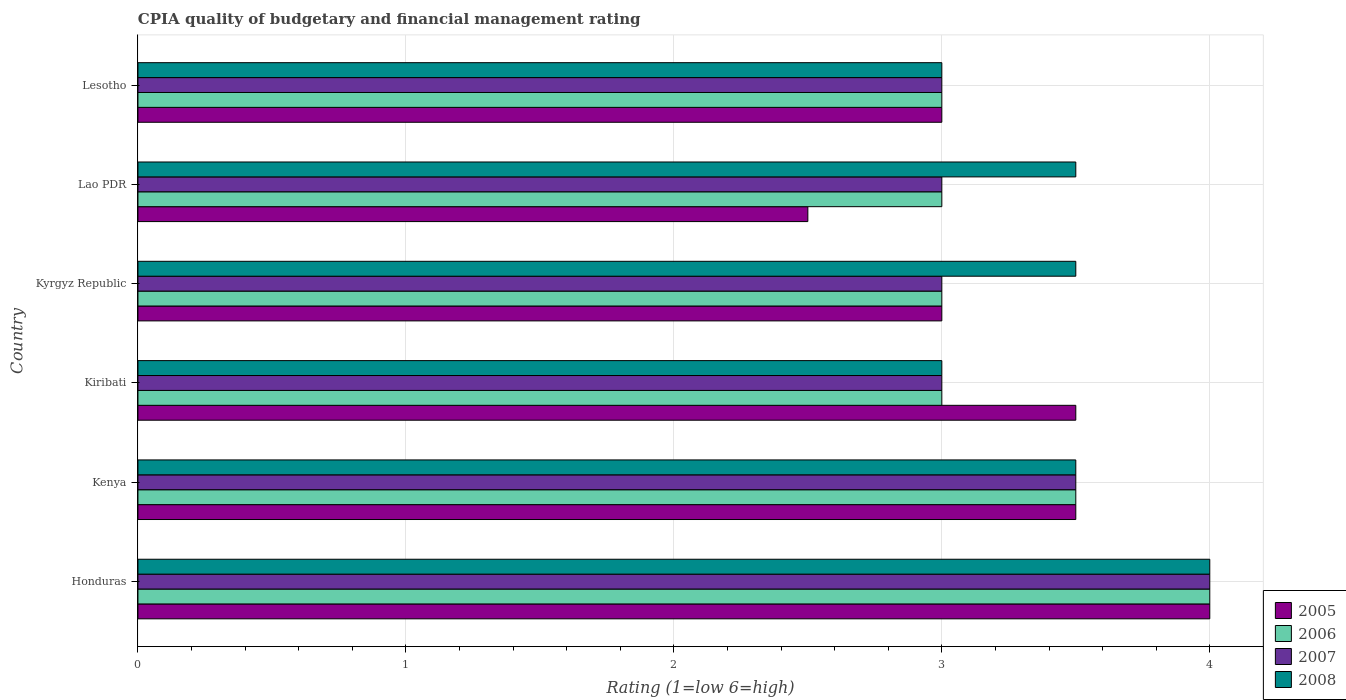Are the number of bars per tick equal to the number of legend labels?
Your answer should be compact. Yes. Are the number of bars on each tick of the Y-axis equal?
Give a very brief answer. Yes. How many bars are there on the 5th tick from the bottom?
Give a very brief answer. 4. What is the label of the 4th group of bars from the top?
Your answer should be compact. Kiribati. What is the CPIA rating in 2007 in Kenya?
Provide a succinct answer. 3.5. Across all countries, what is the minimum CPIA rating in 2008?
Make the answer very short. 3. In which country was the CPIA rating in 2008 maximum?
Provide a succinct answer. Honduras. In which country was the CPIA rating in 2008 minimum?
Keep it short and to the point. Kiribati. What is the difference between the CPIA rating in 2007 in Kyrgyz Republic and that in Lao PDR?
Offer a very short reply. 0. What is the difference between the CPIA rating in 2007 in Honduras and the CPIA rating in 2005 in Kiribati?
Your response must be concise. 0.5. What is the average CPIA rating in 2007 per country?
Give a very brief answer. 3.25. What is the difference between the CPIA rating in 2007 and CPIA rating in 2006 in Kiribati?
Provide a short and direct response. 0. What is the ratio of the CPIA rating in 2008 in Kenya to that in Kyrgyz Republic?
Your response must be concise. 1. Is the difference between the CPIA rating in 2007 in Lao PDR and Lesotho greater than the difference between the CPIA rating in 2006 in Lao PDR and Lesotho?
Make the answer very short. No. What is the difference between the highest and the lowest CPIA rating in 2007?
Keep it short and to the point. 1. Is the sum of the CPIA rating in 2008 in Honduras and Kyrgyz Republic greater than the maximum CPIA rating in 2005 across all countries?
Ensure brevity in your answer.  Yes. Is it the case that in every country, the sum of the CPIA rating in 2008 and CPIA rating in 2005 is greater than the CPIA rating in 2006?
Your answer should be very brief. Yes. How many bars are there?
Provide a succinct answer. 24. What is the difference between two consecutive major ticks on the X-axis?
Make the answer very short. 1. Are the values on the major ticks of X-axis written in scientific E-notation?
Your answer should be very brief. No. How are the legend labels stacked?
Your response must be concise. Vertical. What is the title of the graph?
Your answer should be very brief. CPIA quality of budgetary and financial management rating. Does "1976" appear as one of the legend labels in the graph?
Offer a very short reply. No. What is the Rating (1=low 6=high) in 2006 in Honduras?
Your answer should be very brief. 4. What is the Rating (1=low 6=high) in 2008 in Honduras?
Make the answer very short. 4. What is the Rating (1=low 6=high) in 2007 in Kenya?
Your response must be concise. 3.5. What is the Rating (1=low 6=high) of 2008 in Kenya?
Give a very brief answer. 3.5. What is the Rating (1=low 6=high) of 2005 in Kiribati?
Keep it short and to the point. 3.5. What is the Rating (1=low 6=high) in 2006 in Kiribati?
Provide a succinct answer. 3. What is the Rating (1=low 6=high) of 2007 in Kiribati?
Provide a succinct answer. 3. What is the Rating (1=low 6=high) of 2008 in Kiribati?
Ensure brevity in your answer.  3. What is the Rating (1=low 6=high) in 2005 in Kyrgyz Republic?
Provide a succinct answer. 3. What is the Rating (1=low 6=high) of 2007 in Kyrgyz Republic?
Your answer should be very brief. 3. What is the Rating (1=low 6=high) in 2008 in Kyrgyz Republic?
Provide a succinct answer. 3.5. What is the Rating (1=low 6=high) in 2006 in Lao PDR?
Keep it short and to the point. 3. What is the Rating (1=low 6=high) of 2007 in Lao PDR?
Provide a short and direct response. 3. What is the Rating (1=low 6=high) of 2008 in Lao PDR?
Provide a succinct answer. 3.5. What is the Rating (1=low 6=high) of 2005 in Lesotho?
Provide a succinct answer. 3. Across all countries, what is the maximum Rating (1=low 6=high) of 2007?
Offer a terse response. 4. Across all countries, what is the minimum Rating (1=low 6=high) of 2005?
Offer a very short reply. 2.5. Across all countries, what is the minimum Rating (1=low 6=high) of 2007?
Keep it short and to the point. 3. What is the total Rating (1=low 6=high) of 2007 in the graph?
Give a very brief answer. 19.5. What is the total Rating (1=low 6=high) in 2008 in the graph?
Make the answer very short. 20.5. What is the difference between the Rating (1=low 6=high) of 2005 in Honduras and that in Kenya?
Your answer should be very brief. 0.5. What is the difference between the Rating (1=low 6=high) of 2007 in Honduras and that in Kenya?
Offer a very short reply. 0.5. What is the difference between the Rating (1=low 6=high) of 2005 in Honduras and that in Kiribati?
Provide a short and direct response. 0.5. What is the difference between the Rating (1=low 6=high) of 2008 in Honduras and that in Kiribati?
Ensure brevity in your answer.  1. What is the difference between the Rating (1=low 6=high) in 2006 in Honduras and that in Kyrgyz Republic?
Provide a succinct answer. 1. What is the difference between the Rating (1=low 6=high) in 2008 in Honduras and that in Kyrgyz Republic?
Your answer should be very brief. 0.5. What is the difference between the Rating (1=low 6=high) in 2005 in Honduras and that in Lao PDR?
Keep it short and to the point. 1.5. What is the difference between the Rating (1=low 6=high) of 2007 in Honduras and that in Lao PDR?
Give a very brief answer. 1. What is the difference between the Rating (1=low 6=high) of 2006 in Honduras and that in Lesotho?
Offer a very short reply. 1. What is the difference between the Rating (1=low 6=high) in 2005 in Kenya and that in Kiribati?
Ensure brevity in your answer.  0. What is the difference between the Rating (1=low 6=high) in 2005 in Kenya and that in Kyrgyz Republic?
Offer a terse response. 0.5. What is the difference between the Rating (1=low 6=high) of 2007 in Kenya and that in Kyrgyz Republic?
Provide a short and direct response. 0.5. What is the difference between the Rating (1=low 6=high) of 2005 in Kenya and that in Lao PDR?
Ensure brevity in your answer.  1. What is the difference between the Rating (1=low 6=high) in 2006 in Kenya and that in Lao PDR?
Ensure brevity in your answer.  0.5. What is the difference between the Rating (1=low 6=high) of 2007 in Kenya and that in Lao PDR?
Ensure brevity in your answer.  0.5. What is the difference between the Rating (1=low 6=high) of 2006 in Kenya and that in Lesotho?
Ensure brevity in your answer.  0.5. What is the difference between the Rating (1=low 6=high) in 2007 in Kenya and that in Lesotho?
Your answer should be very brief. 0.5. What is the difference between the Rating (1=low 6=high) of 2008 in Kenya and that in Lesotho?
Give a very brief answer. 0.5. What is the difference between the Rating (1=low 6=high) of 2007 in Kiribati and that in Kyrgyz Republic?
Your answer should be very brief. 0. What is the difference between the Rating (1=low 6=high) in 2008 in Kiribati and that in Kyrgyz Republic?
Offer a very short reply. -0.5. What is the difference between the Rating (1=low 6=high) in 2005 in Kiribati and that in Lao PDR?
Offer a very short reply. 1. What is the difference between the Rating (1=low 6=high) of 2008 in Kiribati and that in Lao PDR?
Your answer should be compact. -0.5. What is the difference between the Rating (1=low 6=high) of 2005 in Kiribati and that in Lesotho?
Ensure brevity in your answer.  0.5. What is the difference between the Rating (1=low 6=high) of 2008 in Kiribati and that in Lesotho?
Keep it short and to the point. 0. What is the difference between the Rating (1=low 6=high) in 2006 in Kyrgyz Republic and that in Lao PDR?
Make the answer very short. 0. What is the difference between the Rating (1=low 6=high) in 2007 in Kyrgyz Republic and that in Lao PDR?
Offer a very short reply. 0. What is the difference between the Rating (1=low 6=high) in 2005 in Kyrgyz Republic and that in Lesotho?
Your response must be concise. 0. What is the difference between the Rating (1=low 6=high) of 2008 in Kyrgyz Republic and that in Lesotho?
Offer a very short reply. 0.5. What is the difference between the Rating (1=low 6=high) in 2005 in Lao PDR and that in Lesotho?
Make the answer very short. -0.5. What is the difference between the Rating (1=low 6=high) of 2006 in Lao PDR and that in Lesotho?
Your answer should be very brief. 0. What is the difference between the Rating (1=low 6=high) in 2007 in Lao PDR and that in Lesotho?
Your answer should be compact. 0. What is the difference between the Rating (1=low 6=high) in 2005 in Honduras and the Rating (1=low 6=high) in 2007 in Kenya?
Make the answer very short. 0.5. What is the difference between the Rating (1=low 6=high) in 2005 in Honduras and the Rating (1=low 6=high) in 2008 in Kenya?
Keep it short and to the point. 0.5. What is the difference between the Rating (1=low 6=high) in 2006 in Honduras and the Rating (1=low 6=high) in 2008 in Kenya?
Give a very brief answer. 0.5. What is the difference between the Rating (1=low 6=high) of 2005 in Honduras and the Rating (1=low 6=high) of 2006 in Kiribati?
Give a very brief answer. 1. What is the difference between the Rating (1=low 6=high) in 2005 in Honduras and the Rating (1=low 6=high) in 2007 in Kiribati?
Make the answer very short. 1. What is the difference between the Rating (1=low 6=high) in 2005 in Honduras and the Rating (1=low 6=high) in 2006 in Kyrgyz Republic?
Provide a succinct answer. 1. What is the difference between the Rating (1=low 6=high) in 2005 in Honduras and the Rating (1=low 6=high) in 2008 in Kyrgyz Republic?
Your response must be concise. 0.5. What is the difference between the Rating (1=low 6=high) of 2006 in Honduras and the Rating (1=low 6=high) of 2008 in Kyrgyz Republic?
Provide a succinct answer. 0.5. What is the difference between the Rating (1=low 6=high) in 2007 in Honduras and the Rating (1=low 6=high) in 2008 in Kyrgyz Republic?
Your answer should be compact. 0.5. What is the difference between the Rating (1=low 6=high) of 2006 in Honduras and the Rating (1=low 6=high) of 2007 in Lao PDR?
Your response must be concise. 1. What is the difference between the Rating (1=low 6=high) of 2005 in Honduras and the Rating (1=low 6=high) of 2007 in Lesotho?
Your response must be concise. 1. What is the difference between the Rating (1=low 6=high) in 2007 in Honduras and the Rating (1=low 6=high) in 2008 in Lesotho?
Your answer should be very brief. 1. What is the difference between the Rating (1=low 6=high) in 2005 in Kenya and the Rating (1=low 6=high) in 2008 in Kiribati?
Provide a succinct answer. 0.5. What is the difference between the Rating (1=low 6=high) of 2006 in Kenya and the Rating (1=low 6=high) of 2008 in Kiribati?
Offer a terse response. 0.5. What is the difference between the Rating (1=low 6=high) in 2005 in Kenya and the Rating (1=low 6=high) in 2006 in Kyrgyz Republic?
Offer a terse response. 0.5. What is the difference between the Rating (1=low 6=high) in 2005 in Kenya and the Rating (1=low 6=high) in 2008 in Kyrgyz Republic?
Provide a succinct answer. 0. What is the difference between the Rating (1=low 6=high) in 2007 in Kenya and the Rating (1=low 6=high) in 2008 in Kyrgyz Republic?
Provide a succinct answer. 0. What is the difference between the Rating (1=low 6=high) of 2005 in Kenya and the Rating (1=low 6=high) of 2006 in Lao PDR?
Keep it short and to the point. 0.5. What is the difference between the Rating (1=low 6=high) in 2005 in Kenya and the Rating (1=low 6=high) in 2007 in Lao PDR?
Your response must be concise. 0.5. What is the difference between the Rating (1=low 6=high) of 2006 in Kenya and the Rating (1=low 6=high) of 2007 in Lao PDR?
Provide a short and direct response. 0.5. What is the difference between the Rating (1=low 6=high) of 2006 in Kenya and the Rating (1=low 6=high) of 2008 in Lao PDR?
Give a very brief answer. 0. What is the difference between the Rating (1=low 6=high) in 2007 in Kenya and the Rating (1=low 6=high) in 2008 in Lao PDR?
Your answer should be compact. 0. What is the difference between the Rating (1=low 6=high) in 2005 in Kenya and the Rating (1=low 6=high) in 2006 in Lesotho?
Ensure brevity in your answer.  0.5. What is the difference between the Rating (1=low 6=high) of 2006 in Kenya and the Rating (1=low 6=high) of 2007 in Lesotho?
Give a very brief answer. 0.5. What is the difference between the Rating (1=low 6=high) in 2006 in Kenya and the Rating (1=low 6=high) in 2008 in Lesotho?
Your response must be concise. 0.5. What is the difference between the Rating (1=low 6=high) of 2007 in Kenya and the Rating (1=low 6=high) of 2008 in Lesotho?
Offer a terse response. 0.5. What is the difference between the Rating (1=low 6=high) of 2005 in Kiribati and the Rating (1=low 6=high) of 2008 in Kyrgyz Republic?
Provide a short and direct response. 0. What is the difference between the Rating (1=low 6=high) of 2006 in Kiribati and the Rating (1=low 6=high) of 2007 in Kyrgyz Republic?
Offer a very short reply. 0. What is the difference between the Rating (1=low 6=high) in 2006 in Kiribati and the Rating (1=low 6=high) in 2008 in Kyrgyz Republic?
Ensure brevity in your answer.  -0.5. What is the difference between the Rating (1=low 6=high) of 2007 in Kiribati and the Rating (1=low 6=high) of 2008 in Kyrgyz Republic?
Your answer should be compact. -0.5. What is the difference between the Rating (1=low 6=high) in 2005 in Kiribati and the Rating (1=low 6=high) in 2006 in Lao PDR?
Offer a terse response. 0.5. What is the difference between the Rating (1=low 6=high) of 2006 in Kiribati and the Rating (1=low 6=high) of 2008 in Lao PDR?
Your answer should be compact. -0.5. What is the difference between the Rating (1=low 6=high) in 2005 in Kiribati and the Rating (1=low 6=high) in 2006 in Lesotho?
Ensure brevity in your answer.  0.5. What is the difference between the Rating (1=low 6=high) in 2005 in Kiribati and the Rating (1=low 6=high) in 2007 in Lesotho?
Give a very brief answer. 0.5. What is the difference between the Rating (1=low 6=high) in 2006 in Kiribati and the Rating (1=low 6=high) in 2007 in Lesotho?
Your answer should be compact. 0. What is the difference between the Rating (1=low 6=high) of 2005 in Kyrgyz Republic and the Rating (1=low 6=high) of 2008 in Lao PDR?
Keep it short and to the point. -0.5. What is the difference between the Rating (1=low 6=high) of 2006 in Kyrgyz Republic and the Rating (1=low 6=high) of 2007 in Lao PDR?
Give a very brief answer. 0. What is the difference between the Rating (1=low 6=high) in 2006 in Kyrgyz Republic and the Rating (1=low 6=high) in 2007 in Lesotho?
Give a very brief answer. 0. What is the difference between the Rating (1=low 6=high) of 2006 in Kyrgyz Republic and the Rating (1=low 6=high) of 2008 in Lesotho?
Provide a succinct answer. 0. What is the difference between the Rating (1=low 6=high) in 2005 in Lao PDR and the Rating (1=low 6=high) in 2006 in Lesotho?
Offer a very short reply. -0.5. What is the difference between the Rating (1=low 6=high) of 2007 in Lao PDR and the Rating (1=low 6=high) of 2008 in Lesotho?
Provide a short and direct response. 0. What is the average Rating (1=low 6=high) in 2007 per country?
Ensure brevity in your answer.  3.25. What is the average Rating (1=low 6=high) in 2008 per country?
Offer a terse response. 3.42. What is the difference between the Rating (1=low 6=high) of 2005 and Rating (1=low 6=high) of 2007 in Honduras?
Your answer should be very brief. 0. What is the difference between the Rating (1=low 6=high) of 2005 and Rating (1=low 6=high) of 2008 in Honduras?
Your answer should be compact. 0. What is the difference between the Rating (1=low 6=high) of 2006 and Rating (1=low 6=high) of 2007 in Honduras?
Offer a terse response. 0. What is the difference between the Rating (1=low 6=high) of 2006 and Rating (1=low 6=high) of 2008 in Honduras?
Your answer should be very brief. 0. What is the difference between the Rating (1=low 6=high) of 2007 and Rating (1=low 6=high) of 2008 in Honduras?
Make the answer very short. 0. What is the difference between the Rating (1=low 6=high) of 2005 and Rating (1=low 6=high) of 2006 in Kenya?
Ensure brevity in your answer.  0. What is the difference between the Rating (1=low 6=high) of 2006 and Rating (1=low 6=high) of 2008 in Kenya?
Your response must be concise. 0. What is the difference between the Rating (1=low 6=high) in 2005 and Rating (1=low 6=high) in 2007 in Kiribati?
Your answer should be compact. 0.5. What is the difference between the Rating (1=low 6=high) of 2005 and Rating (1=low 6=high) of 2008 in Kiribati?
Offer a very short reply. 0.5. What is the difference between the Rating (1=low 6=high) in 2006 and Rating (1=low 6=high) in 2007 in Kiribati?
Keep it short and to the point. 0. What is the difference between the Rating (1=low 6=high) of 2007 and Rating (1=low 6=high) of 2008 in Kiribati?
Your answer should be compact. 0. What is the difference between the Rating (1=low 6=high) in 2005 and Rating (1=low 6=high) in 2006 in Kyrgyz Republic?
Offer a terse response. 0. What is the difference between the Rating (1=low 6=high) of 2005 and Rating (1=low 6=high) of 2008 in Kyrgyz Republic?
Provide a succinct answer. -0.5. What is the difference between the Rating (1=low 6=high) in 2006 and Rating (1=low 6=high) in 2007 in Kyrgyz Republic?
Your response must be concise. 0. What is the difference between the Rating (1=low 6=high) of 2005 and Rating (1=low 6=high) of 2006 in Lao PDR?
Offer a terse response. -0.5. What is the difference between the Rating (1=low 6=high) of 2006 and Rating (1=low 6=high) of 2007 in Lao PDR?
Ensure brevity in your answer.  0. What is the difference between the Rating (1=low 6=high) of 2007 and Rating (1=low 6=high) of 2008 in Lao PDR?
Offer a terse response. -0.5. What is the difference between the Rating (1=low 6=high) in 2005 and Rating (1=low 6=high) in 2007 in Lesotho?
Make the answer very short. 0. What is the difference between the Rating (1=low 6=high) in 2006 and Rating (1=low 6=high) in 2008 in Lesotho?
Provide a succinct answer. 0. What is the ratio of the Rating (1=low 6=high) in 2005 in Honduras to that in Kenya?
Your answer should be very brief. 1.14. What is the ratio of the Rating (1=low 6=high) of 2006 in Honduras to that in Kenya?
Your answer should be very brief. 1.14. What is the ratio of the Rating (1=low 6=high) in 2007 in Honduras to that in Kenya?
Your answer should be very brief. 1.14. What is the ratio of the Rating (1=low 6=high) of 2008 in Honduras to that in Kenya?
Your answer should be compact. 1.14. What is the ratio of the Rating (1=low 6=high) of 2005 in Honduras to that in Kiribati?
Make the answer very short. 1.14. What is the ratio of the Rating (1=low 6=high) in 2008 in Honduras to that in Kiribati?
Offer a terse response. 1.33. What is the ratio of the Rating (1=low 6=high) of 2006 in Honduras to that in Kyrgyz Republic?
Provide a succinct answer. 1.33. What is the ratio of the Rating (1=low 6=high) of 2007 in Honduras to that in Kyrgyz Republic?
Provide a succinct answer. 1.33. What is the ratio of the Rating (1=low 6=high) in 2008 in Honduras to that in Kyrgyz Republic?
Ensure brevity in your answer.  1.14. What is the ratio of the Rating (1=low 6=high) in 2005 in Honduras to that in Lao PDR?
Your response must be concise. 1.6. What is the ratio of the Rating (1=low 6=high) in 2006 in Honduras to that in Lesotho?
Your response must be concise. 1.33. What is the ratio of the Rating (1=low 6=high) of 2005 in Kenya to that in Kiribati?
Ensure brevity in your answer.  1. What is the ratio of the Rating (1=low 6=high) in 2006 in Kenya to that in Kiribati?
Keep it short and to the point. 1.17. What is the ratio of the Rating (1=low 6=high) in 2007 in Kenya to that in Kiribati?
Provide a succinct answer. 1.17. What is the ratio of the Rating (1=low 6=high) of 2008 in Kenya to that in Kiribati?
Your answer should be compact. 1.17. What is the ratio of the Rating (1=low 6=high) of 2007 in Kenya to that in Kyrgyz Republic?
Ensure brevity in your answer.  1.17. What is the ratio of the Rating (1=low 6=high) of 2005 in Kenya to that in Lao PDR?
Give a very brief answer. 1.4. What is the ratio of the Rating (1=low 6=high) of 2006 in Kenya to that in Lao PDR?
Provide a succinct answer. 1.17. What is the ratio of the Rating (1=low 6=high) of 2008 in Kenya to that in Lao PDR?
Your answer should be very brief. 1. What is the ratio of the Rating (1=low 6=high) of 2005 in Kenya to that in Lesotho?
Your answer should be very brief. 1.17. What is the ratio of the Rating (1=low 6=high) of 2007 in Kenya to that in Lesotho?
Provide a short and direct response. 1.17. What is the ratio of the Rating (1=low 6=high) of 2005 in Kiribati to that in Kyrgyz Republic?
Provide a succinct answer. 1.17. What is the ratio of the Rating (1=low 6=high) in 2006 in Kiribati to that in Kyrgyz Republic?
Make the answer very short. 1. What is the ratio of the Rating (1=low 6=high) in 2007 in Kiribati to that in Kyrgyz Republic?
Ensure brevity in your answer.  1. What is the ratio of the Rating (1=low 6=high) in 2006 in Kiribati to that in Lao PDR?
Your answer should be very brief. 1. What is the ratio of the Rating (1=low 6=high) of 2007 in Kiribati to that in Lao PDR?
Your response must be concise. 1. What is the ratio of the Rating (1=low 6=high) of 2005 in Kiribati to that in Lesotho?
Offer a very short reply. 1.17. What is the ratio of the Rating (1=low 6=high) of 2006 in Kyrgyz Republic to that in Lao PDR?
Your answer should be very brief. 1. What is the ratio of the Rating (1=low 6=high) in 2006 in Kyrgyz Republic to that in Lesotho?
Your response must be concise. 1. What is the ratio of the Rating (1=low 6=high) of 2007 in Kyrgyz Republic to that in Lesotho?
Keep it short and to the point. 1. What is the ratio of the Rating (1=low 6=high) in 2005 in Lao PDR to that in Lesotho?
Provide a succinct answer. 0.83. What is the difference between the highest and the second highest Rating (1=low 6=high) of 2007?
Provide a short and direct response. 0.5. What is the difference between the highest and the second highest Rating (1=low 6=high) of 2008?
Your answer should be compact. 0.5. What is the difference between the highest and the lowest Rating (1=low 6=high) in 2005?
Offer a very short reply. 1.5. 